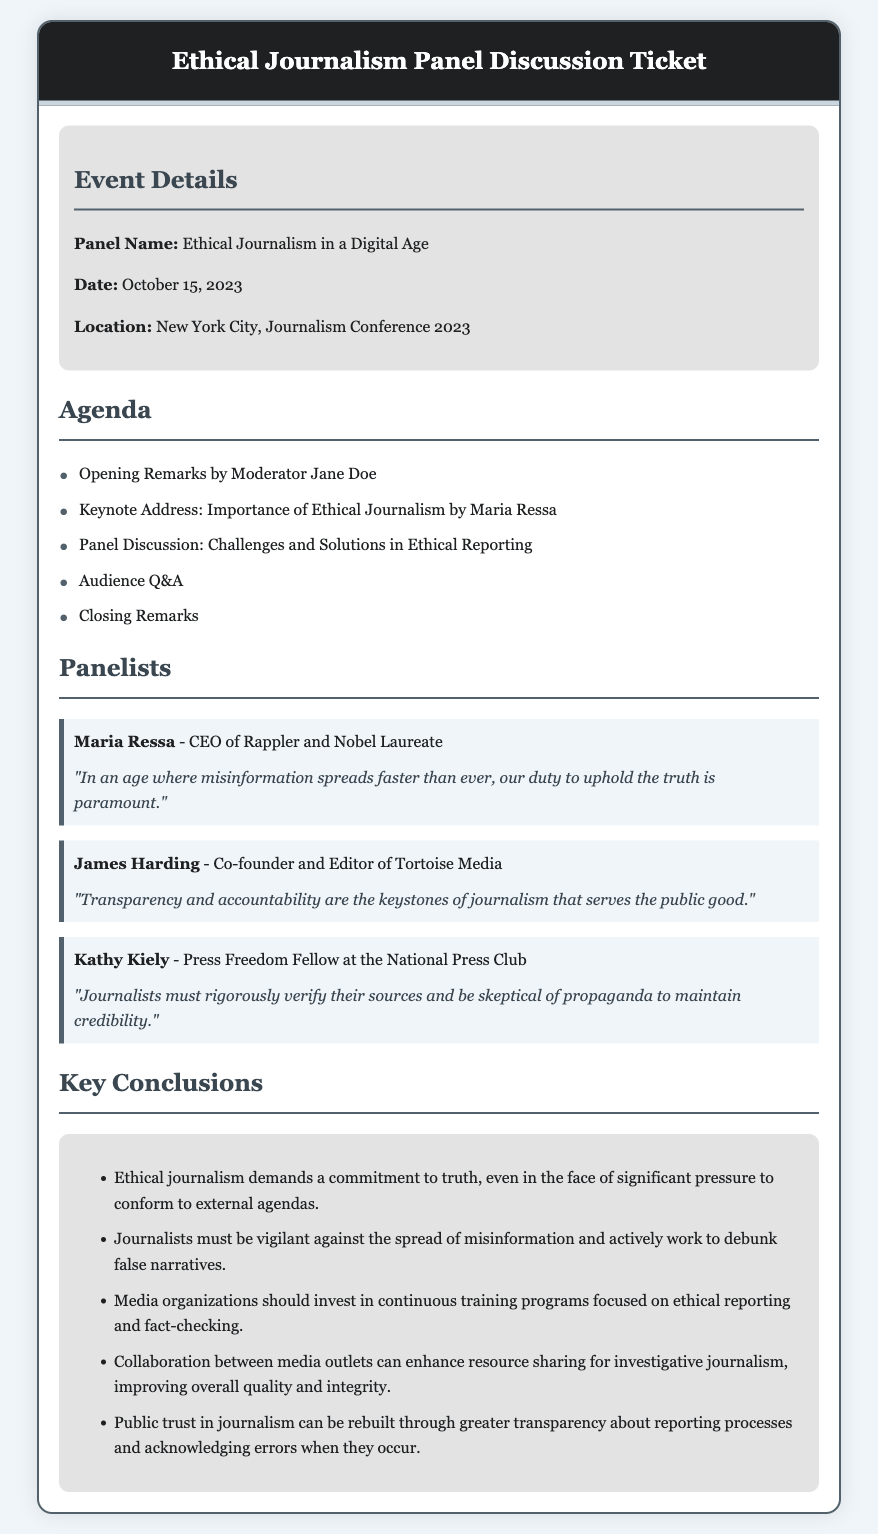What is the panel name? The panel name is mentioned in the document as "Ethical Journalism in a Digital Age."
Answer: Ethical Journalism in a Digital Age Who delivered the keynote address? The keynote address was delivered by Maria Ressa, as stated in the agenda.
Answer: Maria Ressa When did the panel discussion take place? The date of the event is specified in the document as October 15, 2023.
Answer: October 15, 2023 What is one of the key conclusions mentioned about journalists? It states that "journalists must be vigilant against the spread of misinformation" as a key conclusion.
Answer: Journalists must be vigilant against the spread of misinformation Who is the CEO of Rappler? It is noted in the document that Maria Ressa holds the title of CEO of Rappler.
Answer: Maria Ressa What theme do the panelists emphasize regarding trust in journalism? The document mentions that "public trust in journalism can be rebuilt through greater transparency."
Answer: Greater transparency What is the last item on the agenda? The last item listed in the agenda is "Closing Remarks."
Answer: Closing Remarks 